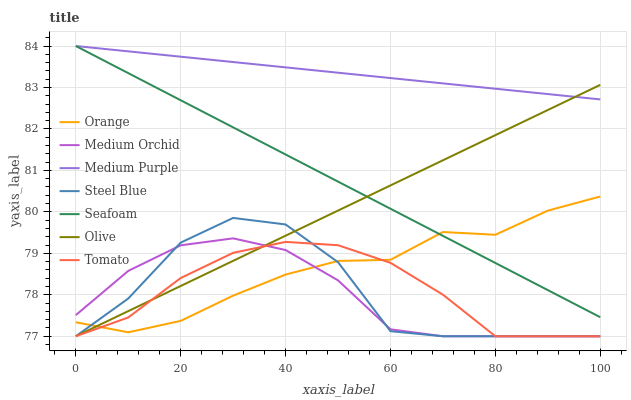Does Medium Orchid have the minimum area under the curve?
Answer yes or no. Yes. Does Medium Purple have the maximum area under the curve?
Answer yes or no. Yes. Does Steel Blue have the minimum area under the curve?
Answer yes or no. No. Does Steel Blue have the maximum area under the curve?
Answer yes or no. No. Is Medium Purple the smoothest?
Answer yes or no. Yes. Is Steel Blue the roughest?
Answer yes or no. Yes. Is Medium Orchid the smoothest?
Answer yes or no. No. Is Medium Orchid the roughest?
Answer yes or no. No. Does Tomato have the lowest value?
Answer yes or no. Yes. Does Seafoam have the lowest value?
Answer yes or no. No. Does Medium Purple have the highest value?
Answer yes or no. Yes. Does Medium Orchid have the highest value?
Answer yes or no. No. Is Steel Blue less than Medium Purple?
Answer yes or no. Yes. Is Seafoam greater than Tomato?
Answer yes or no. Yes. Does Olive intersect Medium Orchid?
Answer yes or no. Yes. Is Olive less than Medium Orchid?
Answer yes or no. No. Is Olive greater than Medium Orchid?
Answer yes or no. No. Does Steel Blue intersect Medium Purple?
Answer yes or no. No. 